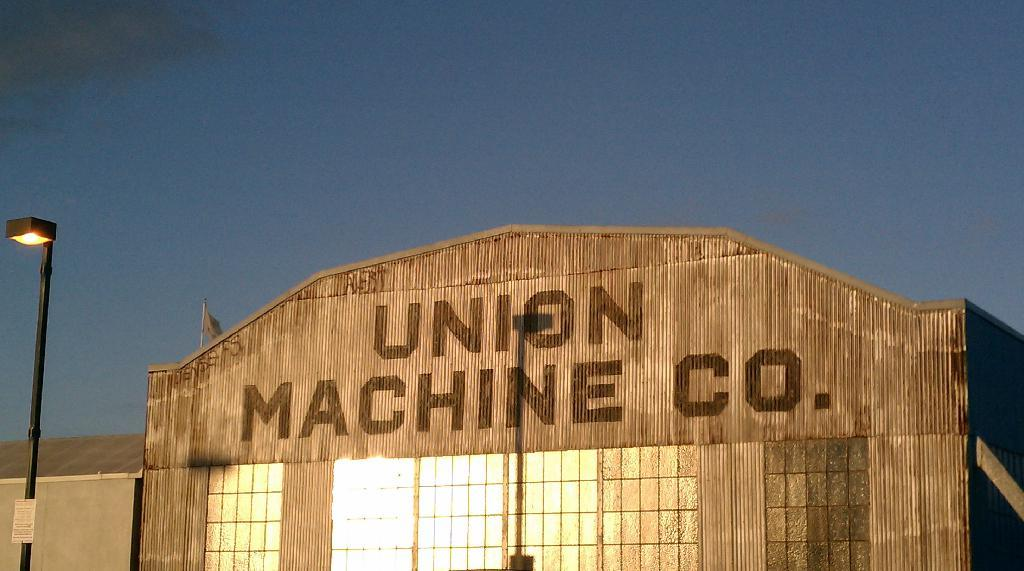What type of structure is present in the image? There is a building in the image. What feature can be seen on the building? The building has windows. What is located on the left side of the image? There is a pole with lights on the left side of the image. What is written or displayed on the building? There is text on the building. What can be seen at the top of the image? The sky is visible at the top of the image. How many sisters are standing in front of the building in the image? There are no sisters present in the image; it only features a building, windows, a pole with lights, text, and the sky. 